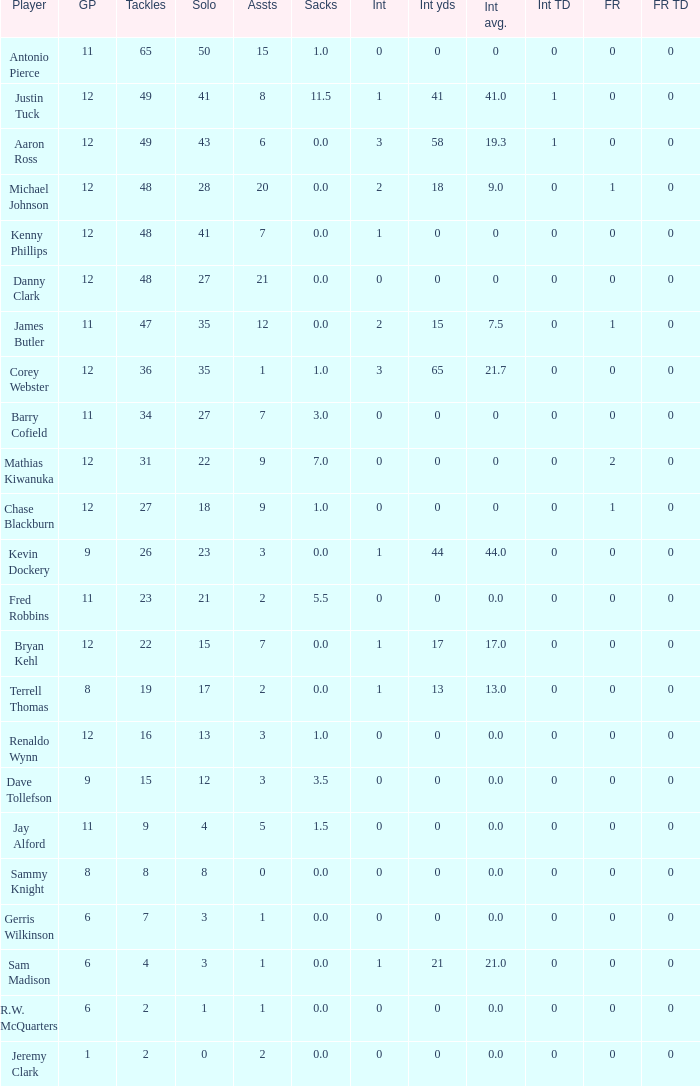Name the least amount of tackles for danny clark 48.0. 